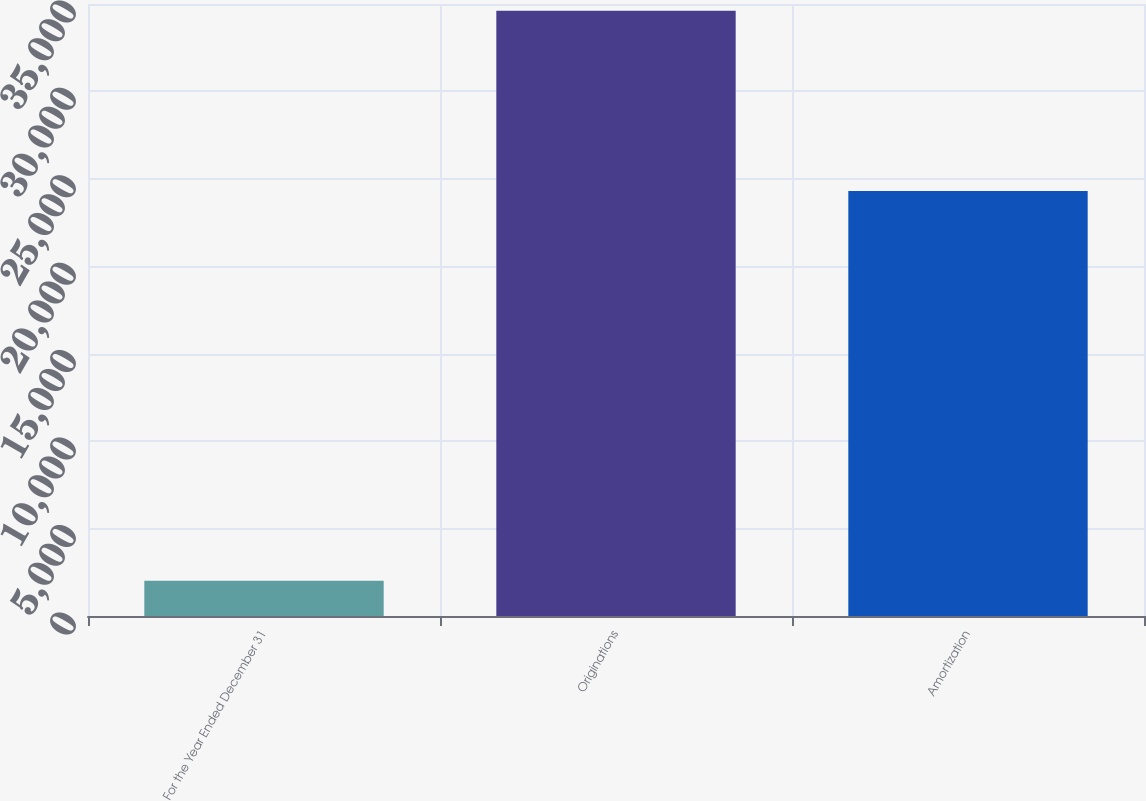Convert chart. <chart><loc_0><loc_0><loc_500><loc_500><bar_chart><fcel>For the Year Ended December 31<fcel>Originations<fcel>Amortization<nl><fcel>2017<fcel>34620<fcel>24308<nl></chart> 